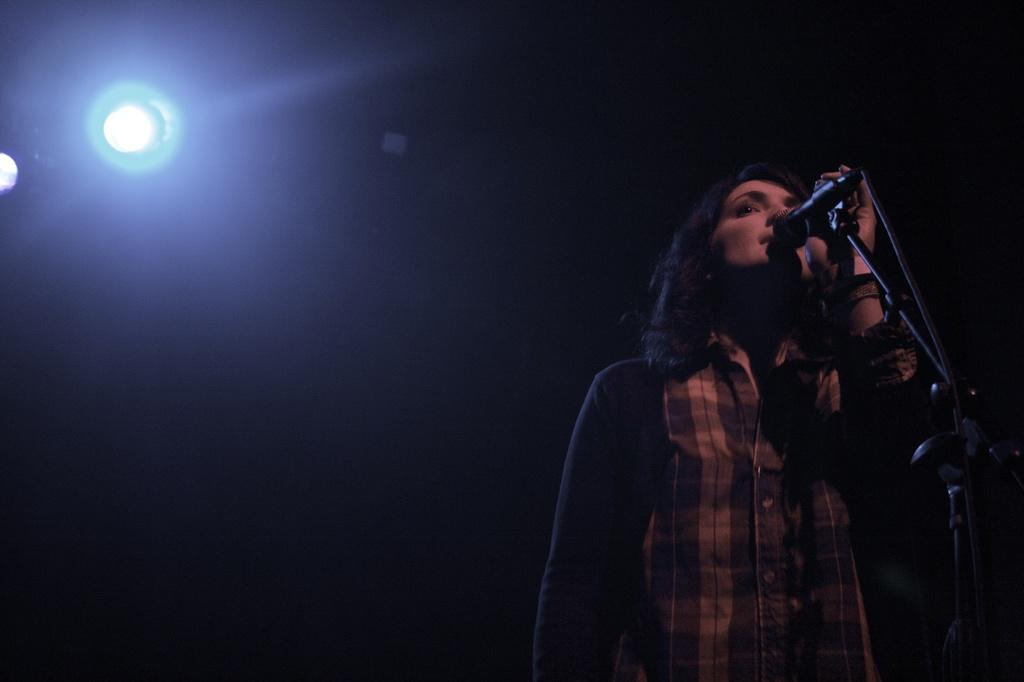Who is the main subject in the foreground of the image? There is a woman in the foreground of the image. What is the woman doing in the image? The woman is standing in front of a microphone. What can be seen in the background of the image? There is a focus light in the background of the image, and the background has a dark color. Where might this image have been taken? The image might have been taken on a stage, given the presence of a microphone and focus light. How many kittens are visible on the stage in the image? There are no kittens present in the image; it features a woman standing in front of a microphone. What type of trade is the woman involved in, as seen in the image? There is no indication of any trade or profession in the image; it only shows a woman standing in front of a microphone. 